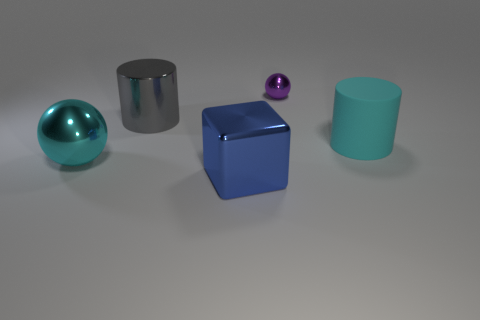What number of red objects are either big spheres or big things?
Offer a very short reply. 0. There is a big cyan rubber cylinder; what number of cyan objects are in front of it?
Your response must be concise. 1. There is a shiny thing behind the cylinder that is behind the big cyan thing behind the large ball; what is its size?
Provide a short and direct response. Small. There is a metallic ball that is to the left of the large cylinder that is to the left of the small purple thing; is there a cyan thing that is behind it?
Give a very brief answer. Yes. Is the number of large blue cubes greater than the number of metallic spheres?
Provide a short and direct response. No. The large shiny object that is behind the cyan metallic object is what color?
Your answer should be compact. Gray. Is the number of balls that are in front of the big gray cylinder greater than the number of large brown metal cubes?
Give a very brief answer. Yes. Is the material of the small ball the same as the large block?
Your answer should be compact. Yes. What number of other objects are the same shape as the blue shiny thing?
Keep it short and to the point. 0. Is there any other thing that is the same material as the big cyan cylinder?
Your response must be concise. No. 